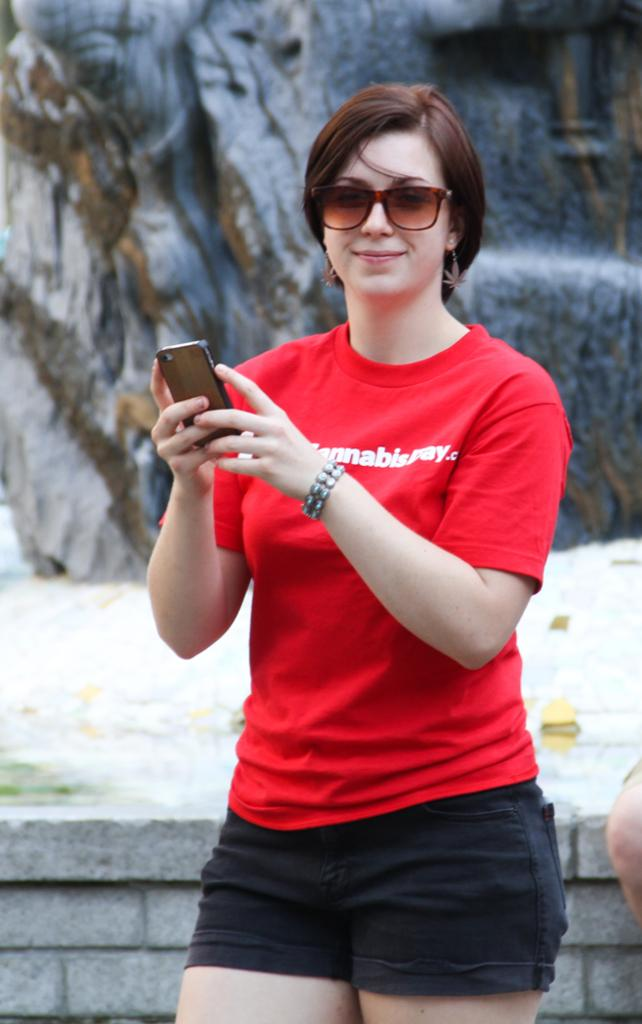Who is the main subject in the image? There is a woman in the image. Where is the woman positioned in the image? The woman is standing in the middle of the image. What is the woman holding in the image? The woman is holding a mobile phone. What is the woman's facial expression in the image? The woman is smiling. What can be seen behind the woman in the image? There is a wall behind the woman. What type of ship can be seen sailing in the background of the image? There is no ship visible in the image; it only features a woman standing in front of a wall. 